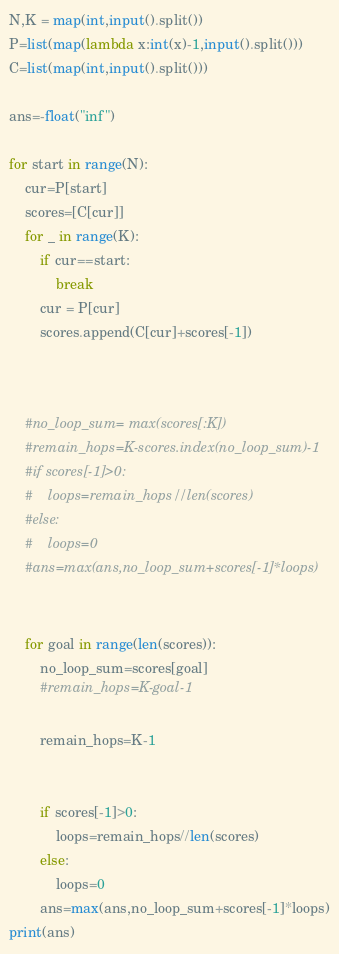<code> <loc_0><loc_0><loc_500><loc_500><_Python_>N,K = map(int,input().split())
P=list(map(lambda x:int(x)-1,input().split()))
C=list(map(int,input().split()))

ans=-float("inf")

for start in range(N):
    cur=P[start]
    scores=[C[cur]]
    for _ in range(K):
        if cur==start:
            break
        cur = P[cur]
        scores.append(C[cur]+scores[-1])


    
    #no_loop_sum= max(scores[:K])
    #remain_hops=K-scores.index(no_loop_sum)-1
    #if scores[-1]>0:
    #    loops=remain_hops//len(scores)
    #else:
    #    loops=0
    #ans=max(ans,no_loop_sum+scores[-1]*loops)

    
    for goal in range(len(scores)):
        no_loop_sum=scores[goal]
        #remain_hops=K-goal-1

        remain_hops=K-1


        if scores[-1]>0:
            loops=remain_hops//len(scores)
        else:
            loops=0
        ans=max(ans,no_loop_sum+scores[-1]*loops)
print(ans)
</code> 